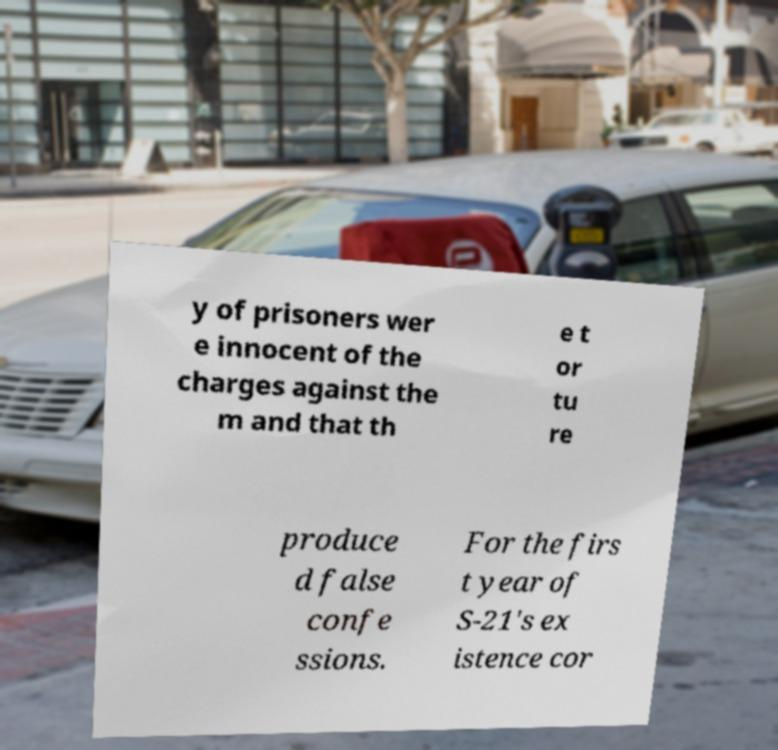Can you accurately transcribe the text from the provided image for me? y of prisoners wer e innocent of the charges against the m and that th e t or tu re produce d false confe ssions. For the firs t year of S-21's ex istence cor 